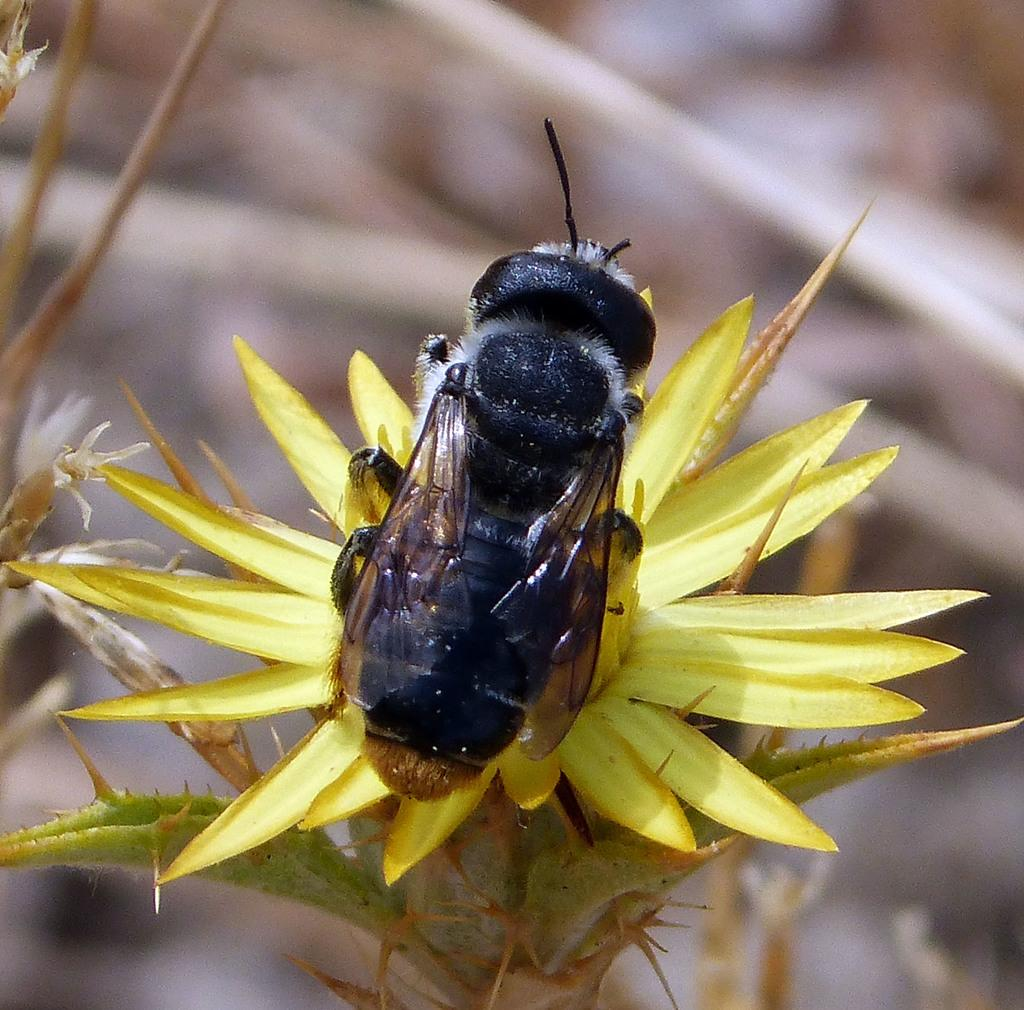What is the main subject of the image? There is a bee in the image. Where is the bee located in the image? The bee is on a yellow flower. Can you describe the background of the image? The background of the image is blurred. What type of silver object can be seen in the image? There is no silver object present in the image. Where is the lunchroom located in the image? There is no lunchroom present in the image. How much salt is visible in the image? There is no salt present in the image. 